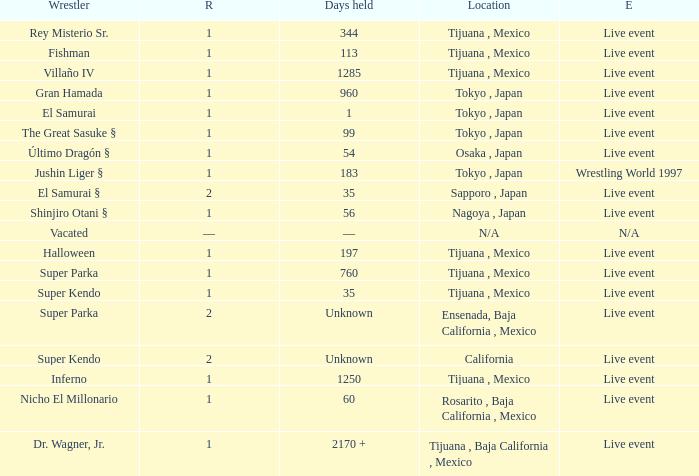What is the reign for super kendo who held it for 35 days? 1.0. 